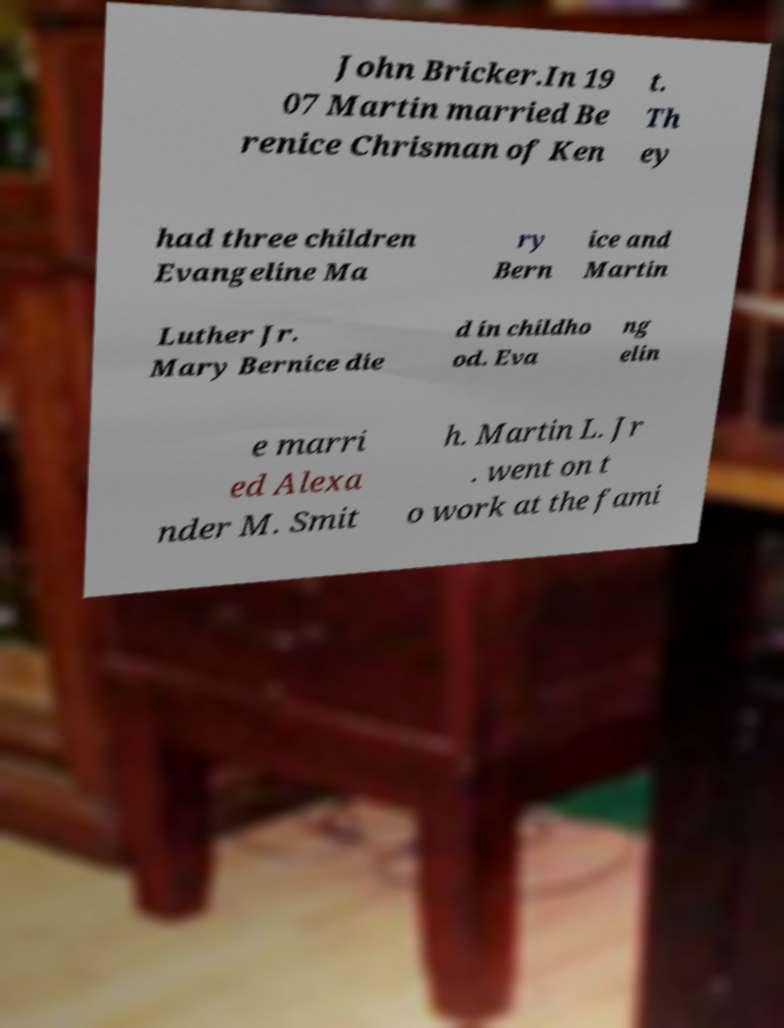Please identify and transcribe the text found in this image. John Bricker.In 19 07 Martin married Be renice Chrisman of Ken t. Th ey had three children Evangeline Ma ry Bern ice and Martin Luther Jr. Mary Bernice die d in childho od. Eva ng elin e marri ed Alexa nder M. Smit h. Martin L. Jr . went on t o work at the fami 